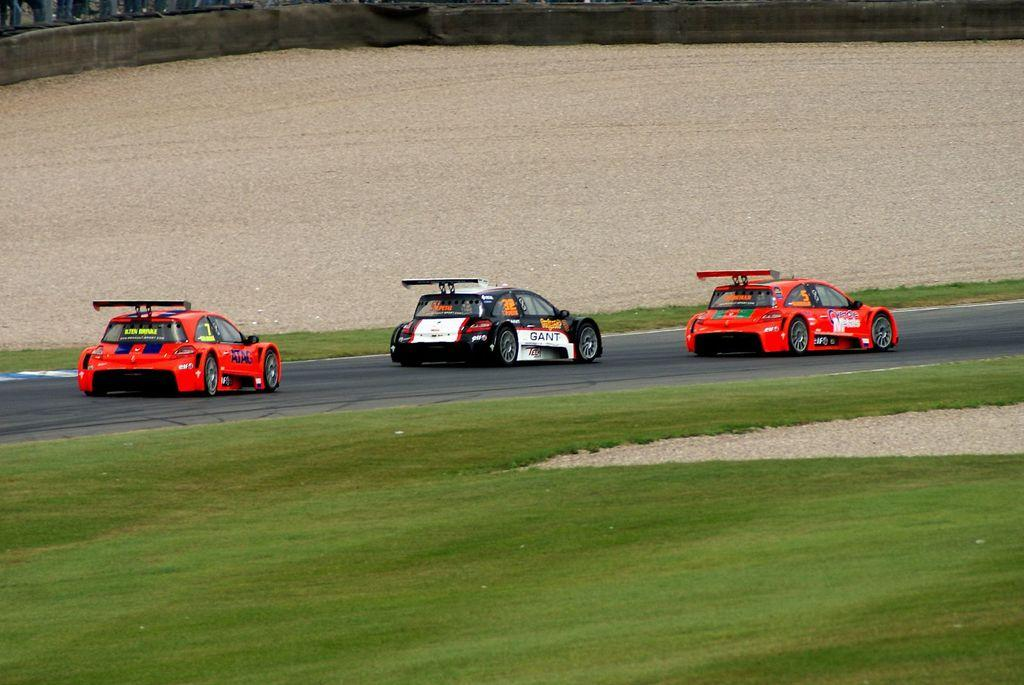How many cars are parked on the road in the image? There are three cars parked on the road in the image. What can be seen in the foreground of the image? There is a grassy field in the foreground. What is visible in the background of the image? There is a wall visible in the background. What type of juice is being served on the roof in the image? There is no juice or roof present in the image. 